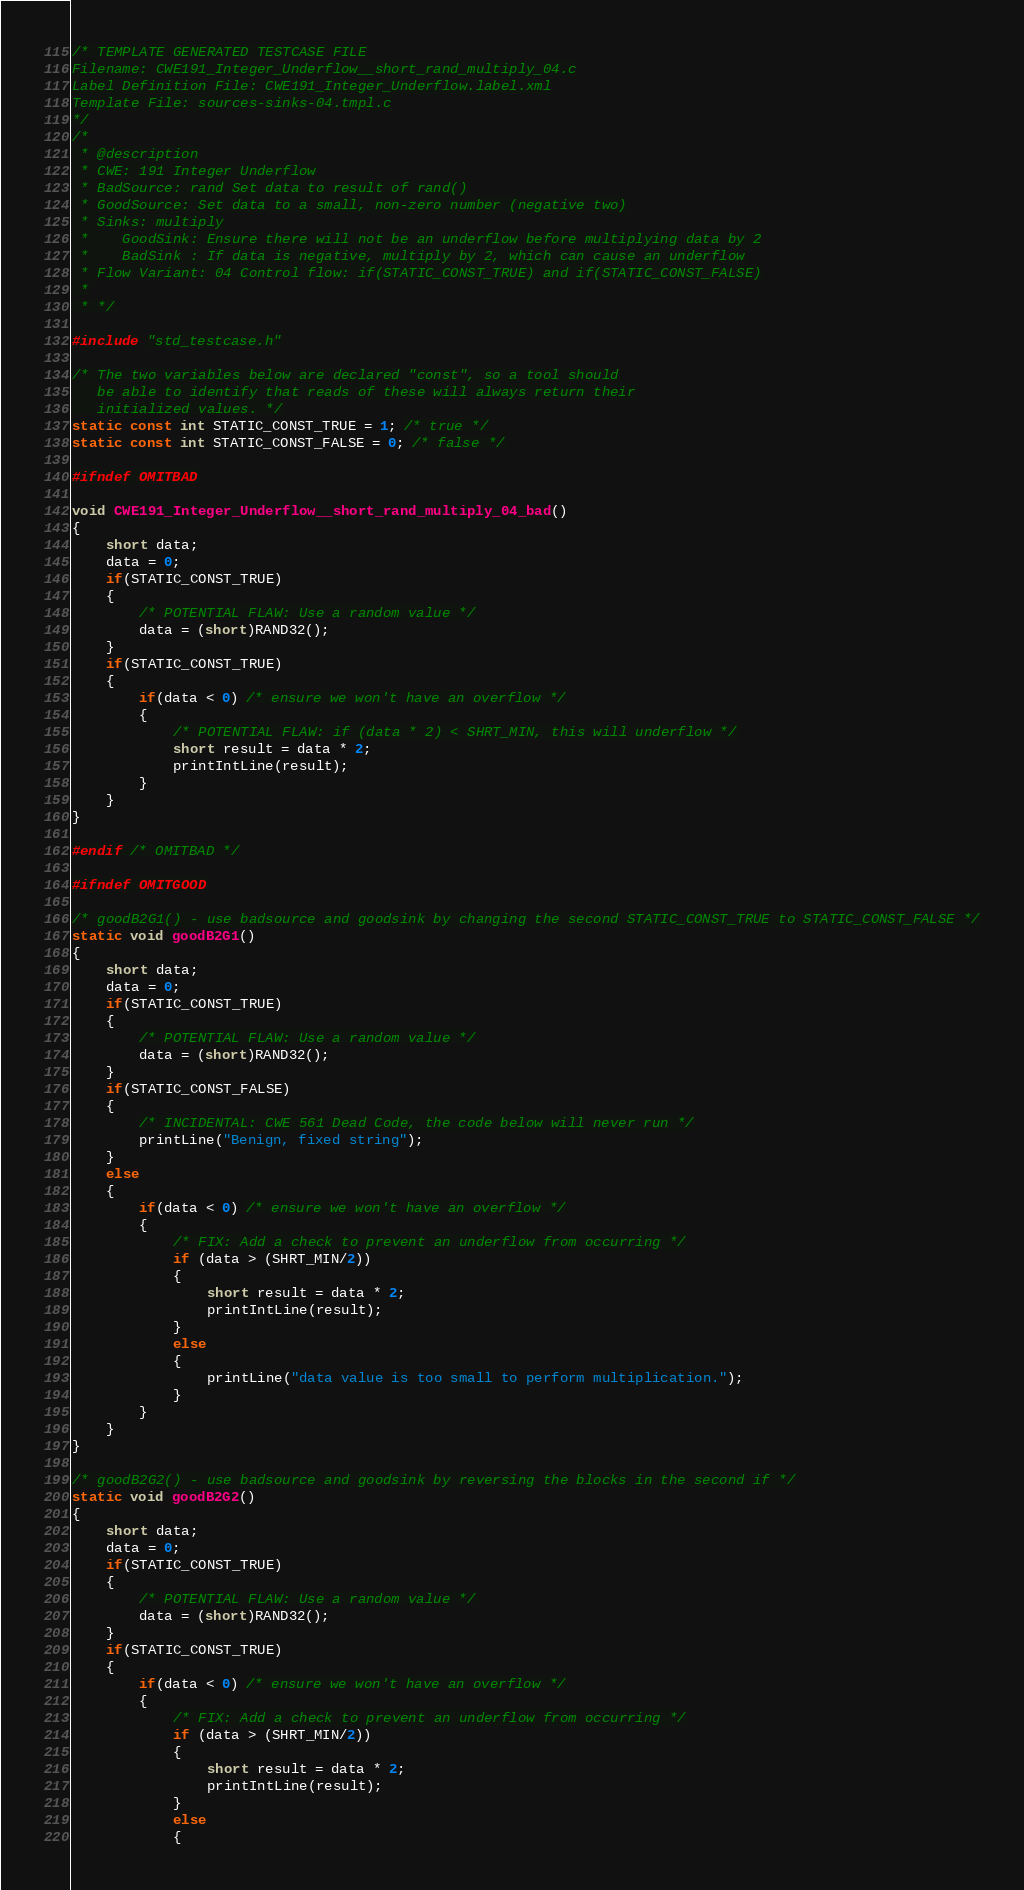<code> <loc_0><loc_0><loc_500><loc_500><_C_>/* TEMPLATE GENERATED TESTCASE FILE
Filename: CWE191_Integer_Underflow__short_rand_multiply_04.c
Label Definition File: CWE191_Integer_Underflow.label.xml
Template File: sources-sinks-04.tmpl.c
*/
/*
 * @description
 * CWE: 191 Integer Underflow
 * BadSource: rand Set data to result of rand()
 * GoodSource: Set data to a small, non-zero number (negative two)
 * Sinks: multiply
 *    GoodSink: Ensure there will not be an underflow before multiplying data by 2
 *    BadSink : If data is negative, multiply by 2, which can cause an underflow
 * Flow Variant: 04 Control flow: if(STATIC_CONST_TRUE) and if(STATIC_CONST_FALSE)
 *
 * */

#include "std_testcase.h"

/* The two variables below are declared "const", so a tool should
   be able to identify that reads of these will always return their
   initialized values. */
static const int STATIC_CONST_TRUE = 1; /* true */
static const int STATIC_CONST_FALSE = 0; /* false */

#ifndef OMITBAD

void CWE191_Integer_Underflow__short_rand_multiply_04_bad()
{
    short data;
    data = 0;
    if(STATIC_CONST_TRUE)
    {
        /* POTENTIAL FLAW: Use a random value */
        data = (short)RAND32();
    }
    if(STATIC_CONST_TRUE)
    {
        if(data < 0) /* ensure we won't have an overflow */
        {
            /* POTENTIAL FLAW: if (data * 2) < SHRT_MIN, this will underflow */
            short result = data * 2;
            printIntLine(result);
        }
    }
}

#endif /* OMITBAD */

#ifndef OMITGOOD

/* goodB2G1() - use badsource and goodsink by changing the second STATIC_CONST_TRUE to STATIC_CONST_FALSE */
static void goodB2G1()
{
    short data;
    data = 0;
    if(STATIC_CONST_TRUE)
    {
        /* POTENTIAL FLAW: Use a random value */
        data = (short)RAND32();
    }
    if(STATIC_CONST_FALSE)
    {
        /* INCIDENTAL: CWE 561 Dead Code, the code below will never run */
        printLine("Benign, fixed string");
    }
    else
    {
        if(data < 0) /* ensure we won't have an overflow */
        {
            /* FIX: Add a check to prevent an underflow from occurring */
            if (data > (SHRT_MIN/2))
            {
                short result = data * 2;
                printIntLine(result);
            }
            else
            {
                printLine("data value is too small to perform multiplication.");
            }
        }
    }
}

/* goodB2G2() - use badsource and goodsink by reversing the blocks in the second if */
static void goodB2G2()
{
    short data;
    data = 0;
    if(STATIC_CONST_TRUE)
    {
        /* POTENTIAL FLAW: Use a random value */
        data = (short)RAND32();
    }
    if(STATIC_CONST_TRUE)
    {
        if(data < 0) /* ensure we won't have an overflow */
        {
            /* FIX: Add a check to prevent an underflow from occurring */
            if (data > (SHRT_MIN/2))
            {
                short result = data * 2;
                printIntLine(result);
            }
            else
            {</code> 